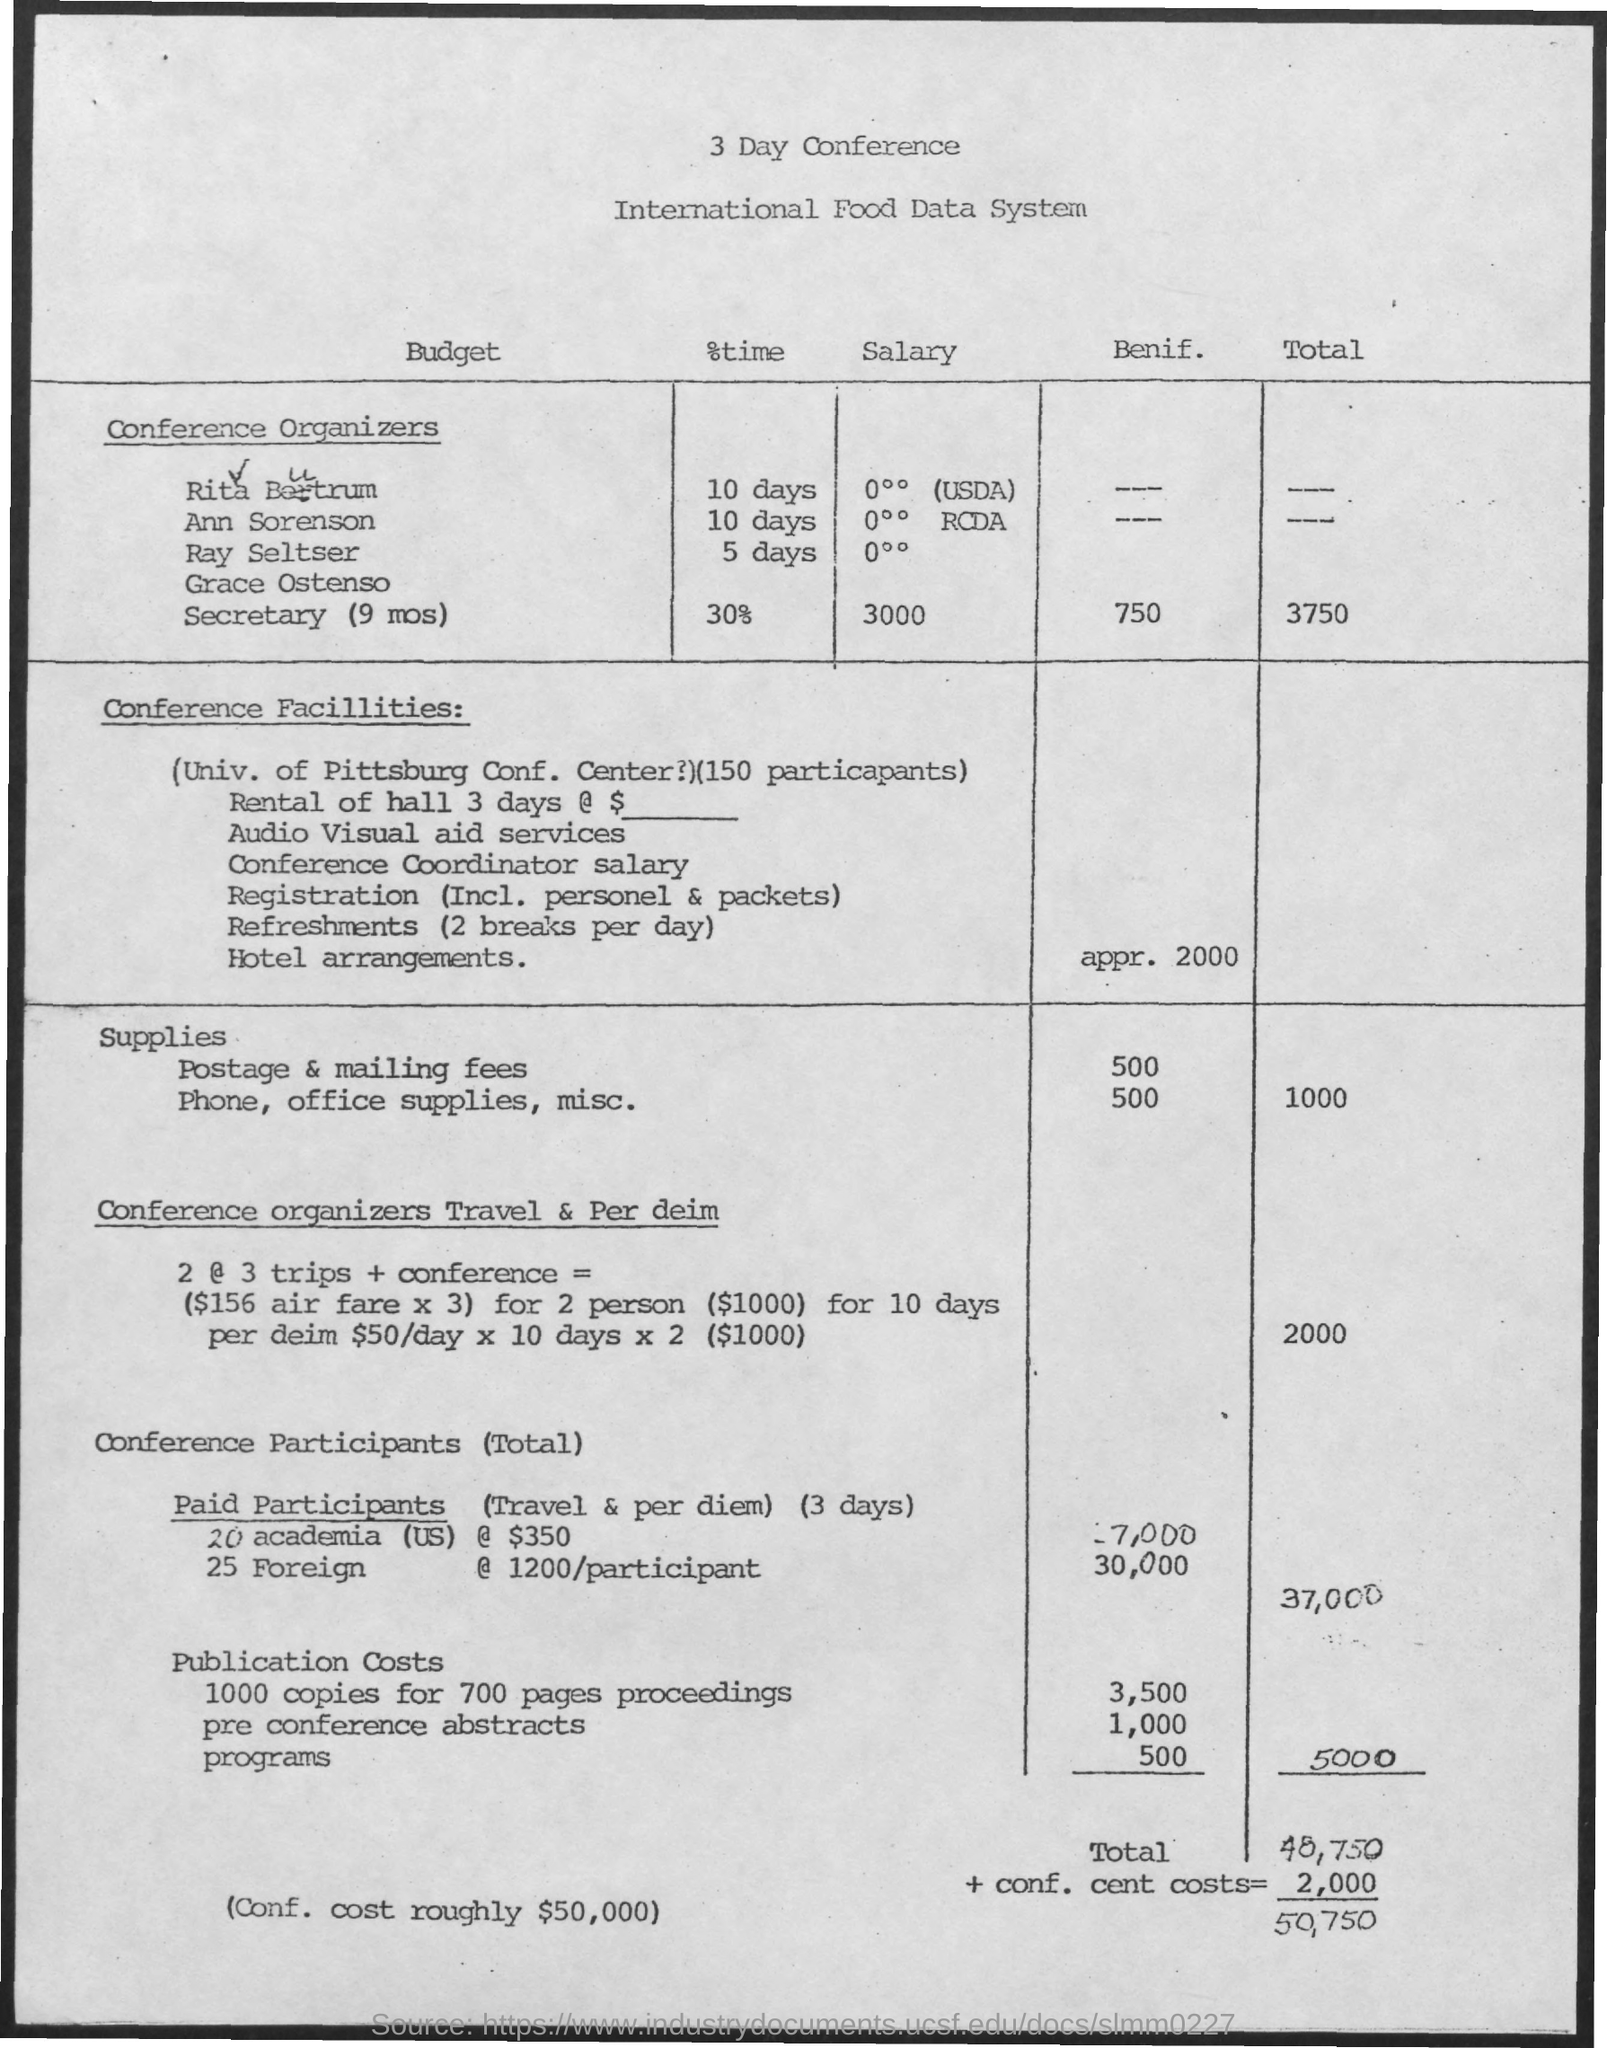What is the conference on?
Provide a succinct answer. International Food Data System. For how many days is the conference?
Give a very brief answer. 3. What is the total + conf. cent costs?
Offer a terse response. 50,750. 